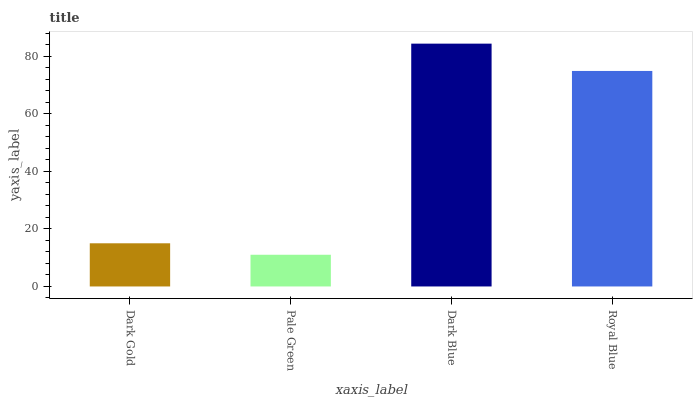Is Pale Green the minimum?
Answer yes or no. Yes. Is Dark Blue the maximum?
Answer yes or no. Yes. Is Dark Blue the minimum?
Answer yes or no. No. Is Pale Green the maximum?
Answer yes or no. No. Is Dark Blue greater than Pale Green?
Answer yes or no. Yes. Is Pale Green less than Dark Blue?
Answer yes or no. Yes. Is Pale Green greater than Dark Blue?
Answer yes or no. No. Is Dark Blue less than Pale Green?
Answer yes or no. No. Is Royal Blue the high median?
Answer yes or no. Yes. Is Dark Gold the low median?
Answer yes or no. Yes. Is Dark Gold the high median?
Answer yes or no. No. Is Pale Green the low median?
Answer yes or no. No. 